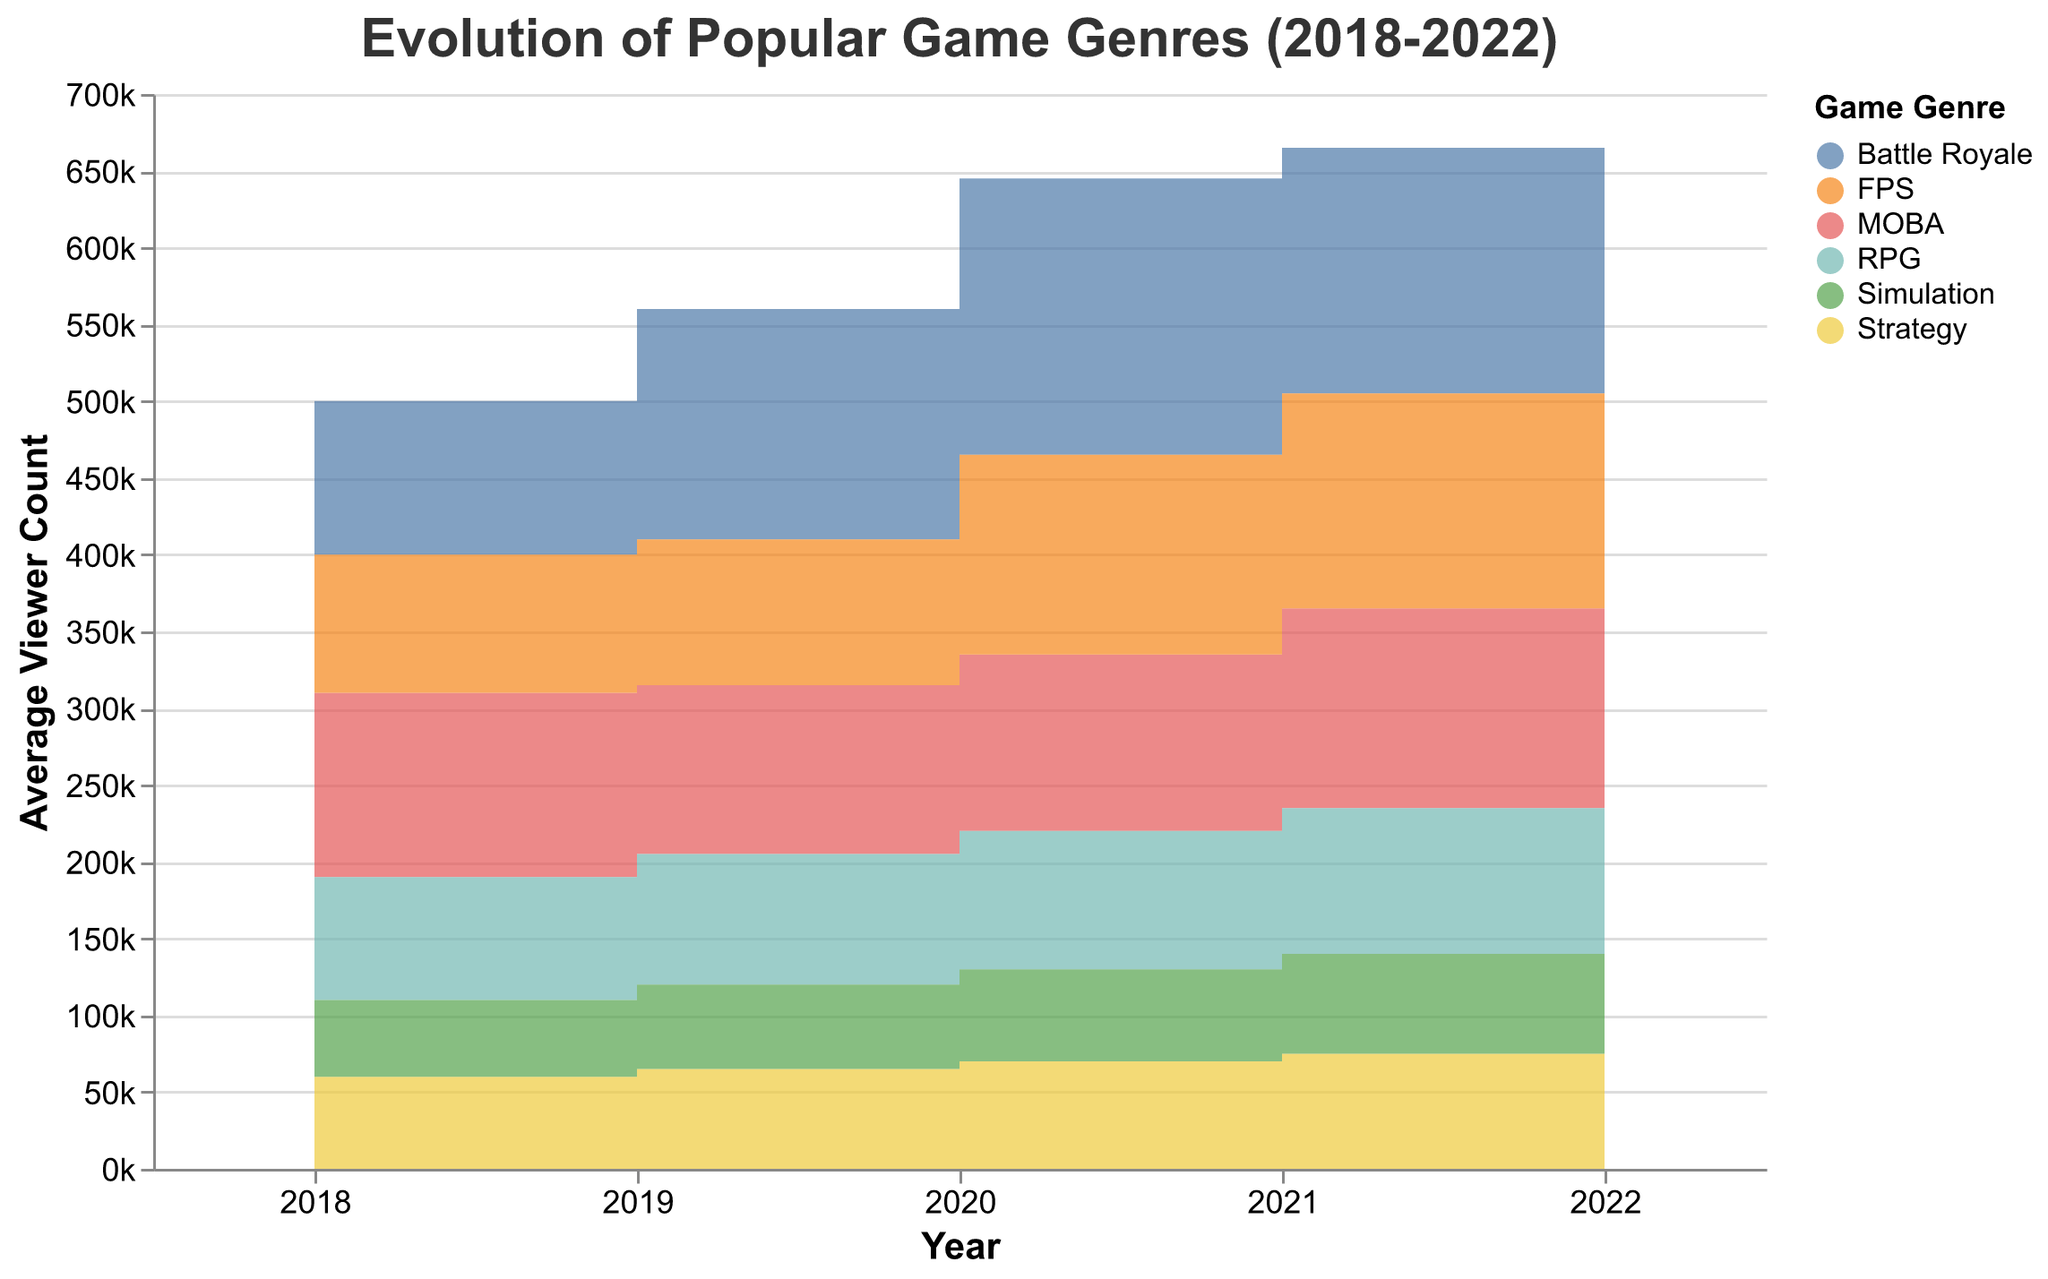What is the title of the figure? The title is usually displayed at the top of the figure in a larger font size. It provides a brief description of what the figure represents. Here, it is indicated that the title is "Evolution of Popular Game Genres (2018-2022)" based on the provided code.
Answer: Evolution of Popular Game Genres (2018-2022) What is the y-axis label? The label of the y-axis describes what the values on the vertical axis represent. According to the provided code, the y-axis label is "Average Viewer Count."
Answer: Average Viewer Count Which genre had the highest average viewer count in 2020? The highest point in the step area chart for 2020 will indicate the genre with the most viewers that year. From the data:
- Battle Royale: 180,000
- MOBA: 115,000
- FPS: 130,000
- RPG: 90,000
- Strategy: 70,000
- Simulation: 60,000
Battle Royale has the highest count.
Answer: Battle Royale How did the average viewer count for FPS games change from 2018 to 2022? To understand the change, look at the viewer count for FPS in 2018 and 2022 and compare them:
- 2018: 90,000
- 2022: 145,000
The count increased from 90,000 to 145,000.
Answer: Increased Which two genres had the most similar viewer counts in 2022? Check the viewer counts for all genres in 2022 and find the two closest values:
- Battle Royale: 140,000
- MOBA: 125,000
- FPS: 145,000
- RPG: 100,000
- Strategy: 80,000
- Simulation: 70,000
MOBA and RPG are closest to each other with 125,000 and 100,000 viewers.
Answer: MOBA and RPG What was the trend in average viewer counts for Battle Royale games from 2018 to 2022? Analyze the viewer counts for Battle Royale over the years:
- 2018: 100,000
- 2019: 150,000
- 2020: 180,000
- 2021: 160,000
- 2022: 140,000
The viewer count increased from 2018 to 2020, then decreased from 2020 to 2022.
Answer: Increased until 2020, then decreased Which genre saw continuous growth in average viewer count from 2018 to 2022? Search for the genre where the viewer numbers steadily rise every year:
- MOBA: Decrease in 2019
- Battle Royale: Peaked in 2020, then decreased
- FPS: Continual increase from 90,000 to 145,000
- RPG: Continual increase from 80,000 to 100,000
- Strategy: Continual increase from 60,000 to 80,000
- Simulation: Continual increase from 50,000 to 70,000
- RPG, Strategy, and Simulation each display continuous growth.
Answer: RPG, Strategy, Simulation Comparing MOBA and RPG, which genre had more average viewers in 2021? Check the average viewer count in 2021 for both genres:
- MOBA: 130,000
- RPG: 95,000
MOBA had more average viewers.
Answer: MOBA By how much did the average viewer count for MOBA games change from 2019 to 2020? Calculate the difference in viewer counts for MOBA between 2019 and 2020:
- 2019: 110,000
- 2020: 115,000
The count increased by 5,000.
Answer: Increased by 5,000 Which genre had the least average viewers in 2018 and how many viewers did it have? Locate the genre with the smallest number on the figure for 2018:
- Battle Royale: 100,000
- MOBA: 120,000
- FPS: 90,000
- RPG: 80,000
- Strategy: 60,000
- Simulation: 50,000
Simulation had the least viewers with 50,000 viewers.
Answer: Simulation, 50,000 